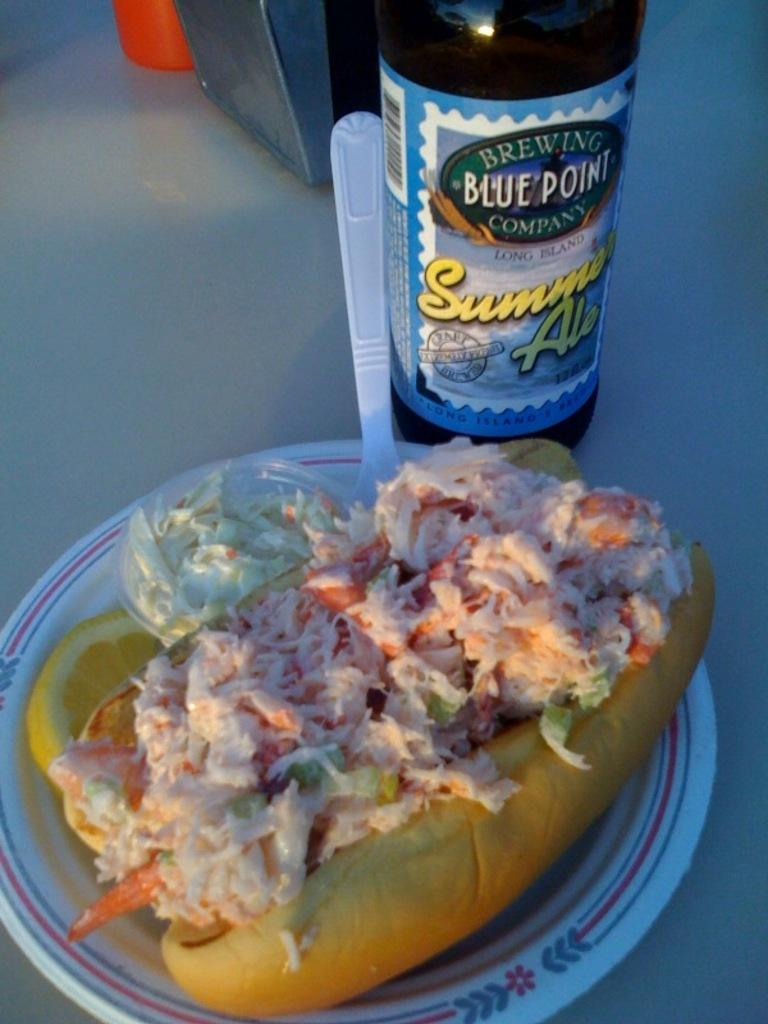<image>
Summarize the visual content of the image. A hot dog with coleslaw next to a bottle of Sunny Ale. 